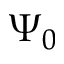<formula> <loc_0><loc_0><loc_500><loc_500>\Psi _ { 0 }</formula> 